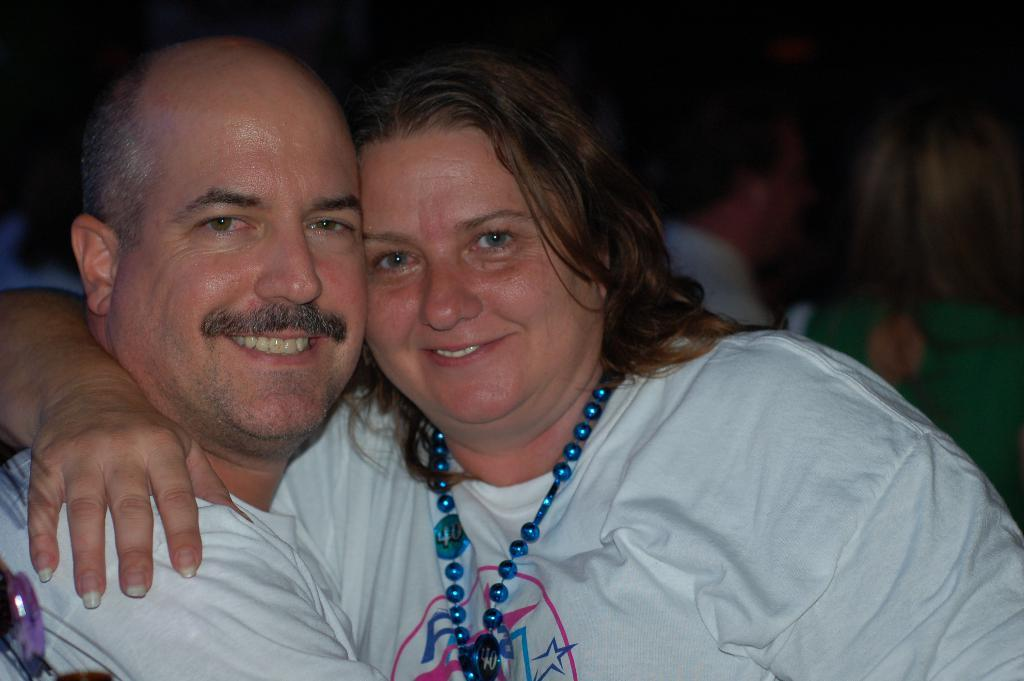How many people are in the image? There are two persons in the image. What expressions do the two persons have on their faces? Both persons are wearing a smile on their faces. Can you describe the background of the image? There are other people visible behind the two persons. What type of boats can be seen in the image? There are no boats present in the image. What kind of linen is being used by the persons in the image? There is no mention of linen in the image, and it is not clear what type of clothing or fabric the persons are wearing. 